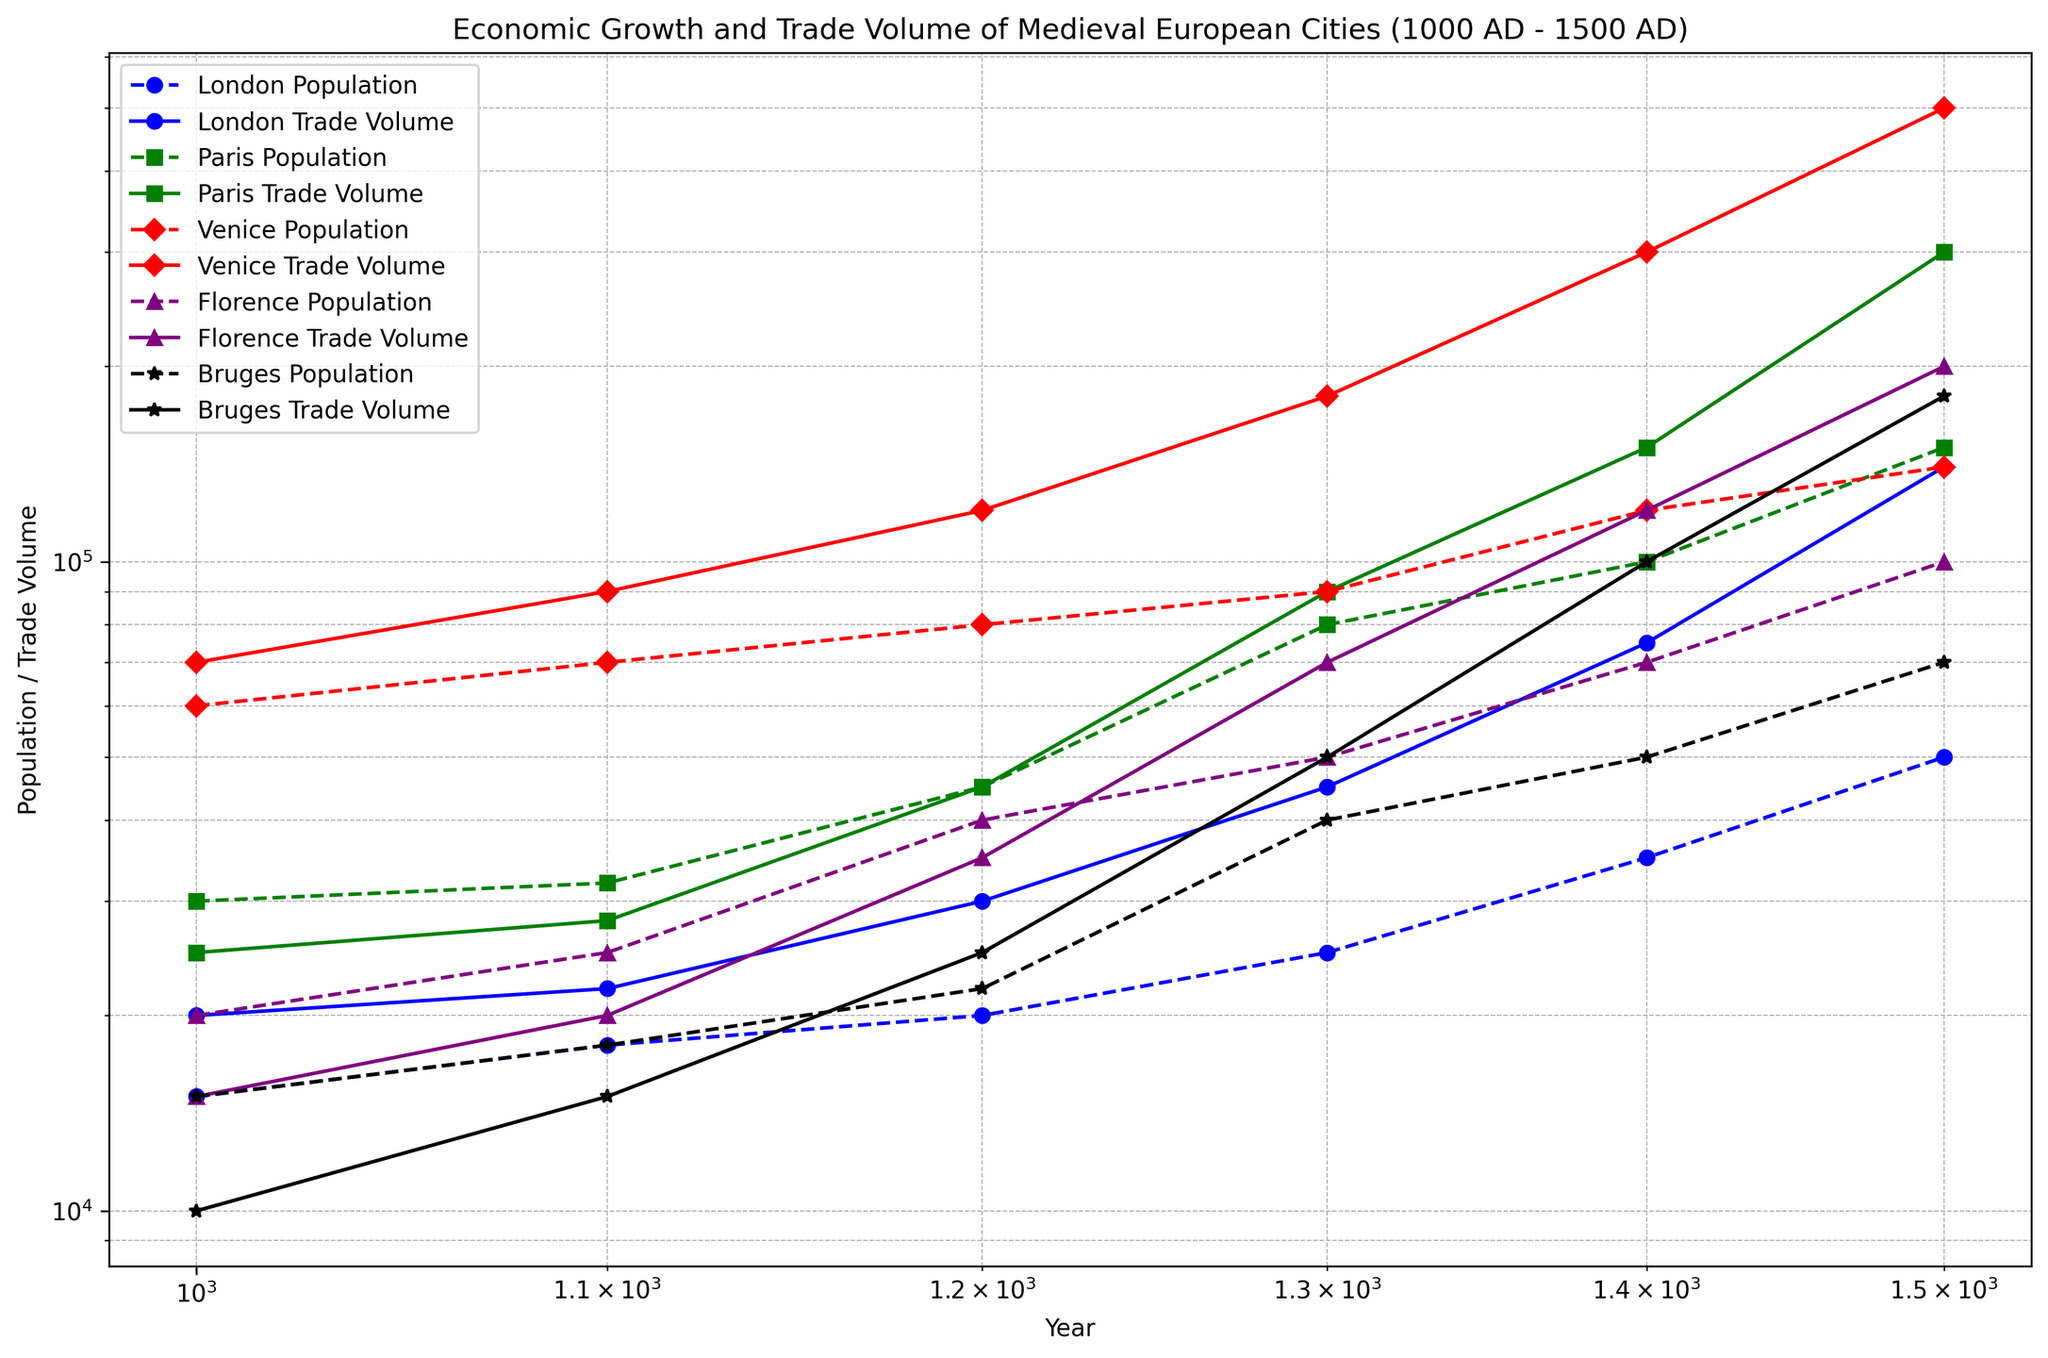Which city had the highest population in 1500? Look at the population data for each city at the year 1500. The city with the highest number is Paris with 150,000.
Answer: Paris By how much did London's trade volume increase from 1000 to 1500? Subtract the trade volume of London in 1000 from its trade volume in 1500. (140,000 - 20,000 = 120,000)
Answer: 120,000 Which city experienced the fastest growth in trade volume between 1300 and 1500? Compare the trade volumes of each city between 1300 and 1500. Calculate the difference for each city. Venice has the largest increase (500,000 - 180,000 = 320,000).
Answer: Venice What was the average population of Paris between 1000 and 1500? Add the population of Paris for all the years considered and then divide by the number of data points (30,000 + 32,000 + 45,000 + 80,000 + 100,000 + 150,000) / 6 = 72,833.33
Answer: 72,833.33 How did the population of Florence in 1400 compare to that of Bruges in the same year? Observe the population values of Florence and Bruges in 1400. Florence had 70,000, and Bruges had 50,000. Florence had a larger population by 20,000.
Answer: Florence was larger by 20,000 Which city had the smallest trade volume in 1300? Examine the trade volumes of all cities in 1300. Bruges had the smallest trade volume with 50,000.
Answer: Bruges What is the trend in the population growth of Venice from 1000 to 1500? Look at the population values of Venice from 1000 to 1500 (60,000, 70,000, 80,000, 90,000, 120,000, 140,000). The population consistently increases over the period.
Answer: Increasing Which city had the highest trade volume in 1200? Inspect the trade volumes of all cities in 1200. Venice had the highest trade volume with 120,000.
Answer: Venice Did any city experience a decrease in population at any point between 1000 and 1500? Examine the population data for each city across the years. All cities show either constant or increasing populations with no decreases.
Answer: No 